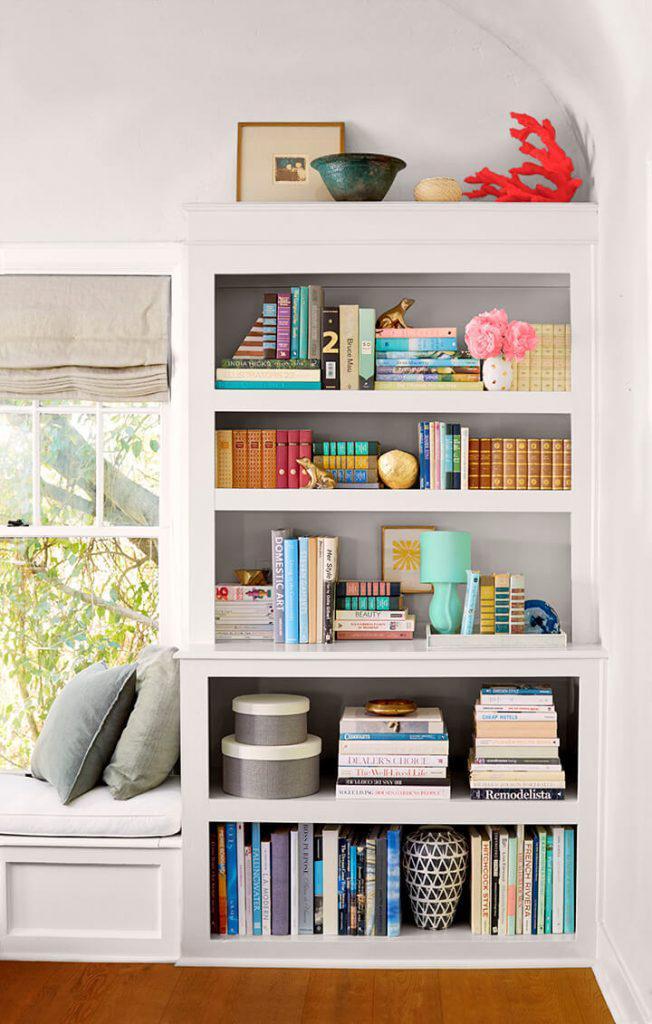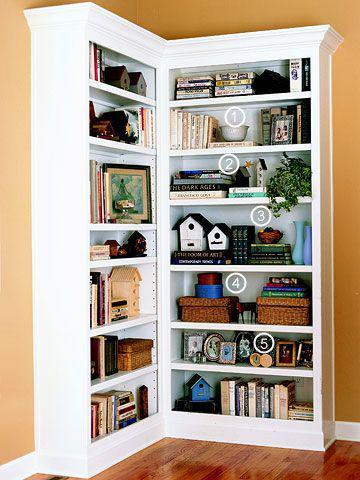The first image is the image on the left, the second image is the image on the right. Given the left and right images, does the statement "An image shows a non-white corner bookshelf that includes at least some open ends" hold true? Answer yes or no. No. The first image is the image on the left, the second image is the image on the right. For the images displayed, is the sentence "The bookshelf on the right covers an entire right-angle corner." factually correct? Answer yes or no. Yes. 